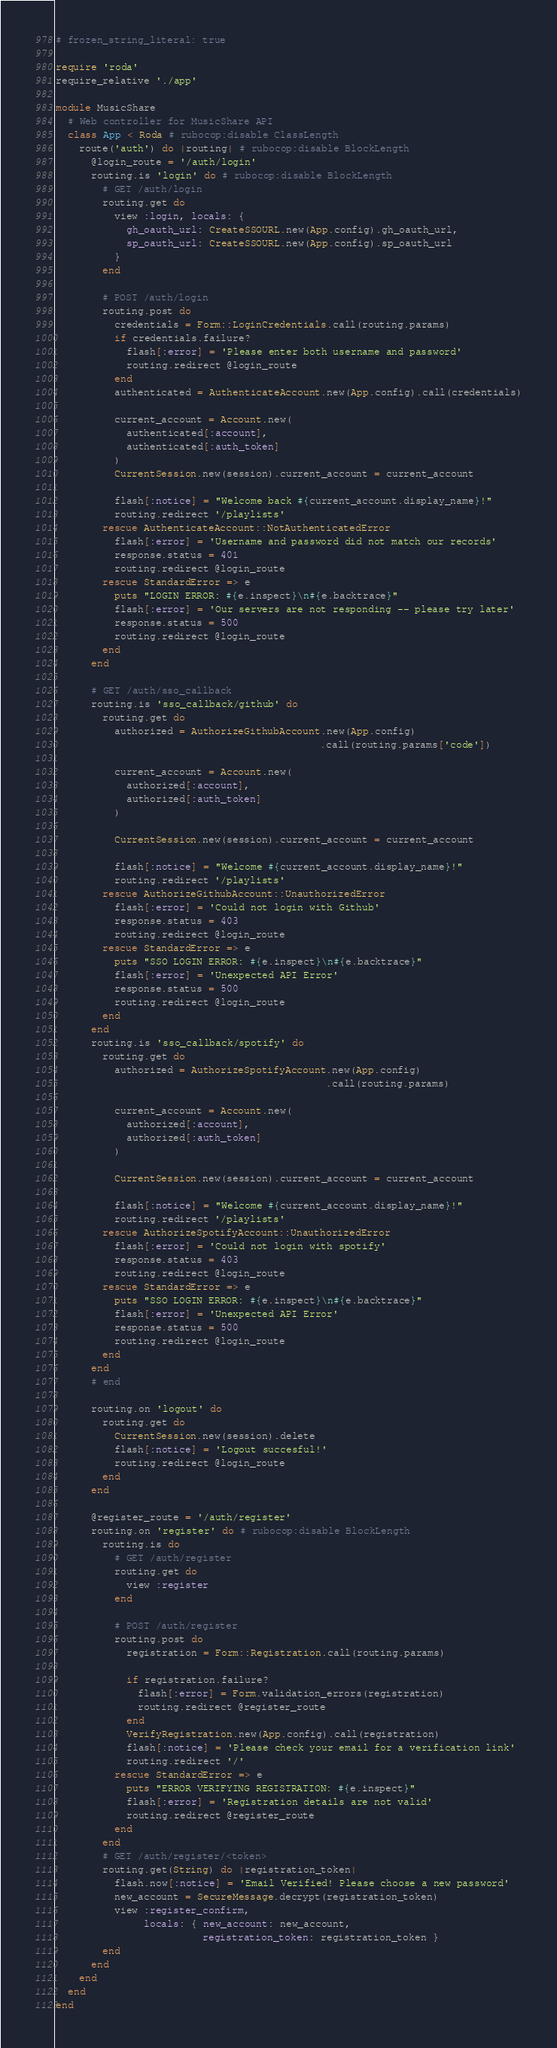Convert code to text. <code><loc_0><loc_0><loc_500><loc_500><_Ruby_># frozen_string_literal: true

require 'roda'
require_relative './app'

module MusicShare
  # Web controller for MusicShare API
  class App < Roda # rubocop:disable ClassLength
    route('auth') do |routing| # rubocop:disable BlockLength
      @login_route = '/auth/login'
      routing.is 'login' do # rubocop:disable BlockLength
        # GET /auth/login
        routing.get do
          view :login, locals: {
            gh_oauth_url: CreateSSOURL.new(App.config).gh_oauth_url,
            sp_oauth_url: CreateSSOURL.new(App.config).sp_oauth_url
          }
        end

        # POST /auth/login
        routing.post do
          credentials = Form::LoginCredentials.call(routing.params)
          if credentials.failure?
            flash[:error] = 'Please enter both username and password'
            routing.redirect @login_route
          end
          authenticated = AuthenticateAccount.new(App.config).call(credentials)

          current_account = Account.new(
            authenticated[:account],
            authenticated[:auth_token]
          )
          CurrentSession.new(session).current_account = current_account

          flash[:notice] = "Welcome back #{current_account.display_name}!"
          routing.redirect '/playlists'
        rescue AuthenticateAccount::NotAuthenticatedError
          flash[:error] = 'Username and password did not match our records'
          response.status = 401
          routing.redirect @login_route
        rescue StandardError => e
          puts "LOGIN ERROR: #{e.inspect}\n#{e.backtrace}"
          flash[:error] = 'Our servers are not responding -- please try later'
          response.status = 500
          routing.redirect @login_route
        end
      end

      # GET /auth/sso_callback
      routing.is 'sso_callback/github' do
        routing.get do
          authorized = AuthorizeGithubAccount.new(App.config)
                                             .call(routing.params['code'])

          current_account = Account.new(
            authorized[:account],
            authorized[:auth_token]
          )

          CurrentSession.new(session).current_account = current_account

          flash[:notice] = "Welcome #{current_account.display_name}!"
          routing.redirect '/playlists'
        rescue AuthorizeGithubAccount::UnauthorizedError
          flash[:error] = 'Could not login with Github'
          response.status = 403
          routing.redirect @login_route
        rescue StandardError => e
          puts "SSO LOGIN ERROR: #{e.inspect}\n#{e.backtrace}"
          flash[:error] = 'Unexpected API Error'
          response.status = 500
          routing.redirect @login_route
        end
      end
      routing.is 'sso_callback/spotify' do
        routing.get do
          authorized = AuthorizeSpotifyAccount.new(App.config)
                                              .call(routing.params)

          current_account = Account.new(
            authorized[:account],
            authorized[:auth_token]
          )

          CurrentSession.new(session).current_account = current_account

          flash[:notice] = "Welcome #{current_account.display_name}!"
          routing.redirect '/playlists'
        rescue AuthorizeSpotifyAccount::UnauthorizedError
          flash[:error] = 'Could not login with spotify'
          response.status = 403
          routing.redirect @login_route
        rescue StandardError => e
          puts "SSO LOGIN ERROR: #{e.inspect}\n#{e.backtrace}"
          flash[:error] = 'Unexpected API Error'
          response.status = 500
          routing.redirect @login_route
        end
      end
      # end

      routing.on 'logout' do
        routing.get do
          CurrentSession.new(session).delete
          flash[:notice] = 'Logout succesful!'
          routing.redirect @login_route
        end
      end

      @register_route = '/auth/register'
      routing.on 'register' do # rubocop:disable BlockLength
        routing.is do
          # GET /auth/register
          routing.get do
            view :register
          end

          # POST /auth/register
          routing.post do
            registration = Form::Registration.call(routing.params)

            if registration.failure?
              flash[:error] = Form.validation_errors(registration)
              routing.redirect @register_route
            end
            VerifyRegistration.new(App.config).call(registration)
            flash[:notice] = 'Please check your email for a verification link'
            routing.redirect '/'
          rescue StandardError => e
            puts "ERROR VERIFYING REGISTRATION: #{e.inspect}"
            flash[:error] = 'Registration details are not valid'
            routing.redirect @register_route
          end
        end
        # GET /auth/register/<token>
        routing.get(String) do |registration_token|
          flash.now[:notice] = 'Email Verified! Please choose a new password'
          new_account = SecureMessage.decrypt(registration_token)
          view :register_confirm,
               locals: { new_account: new_account,
                         registration_token: registration_token }
        end
      end
    end
  end
end
</code> 